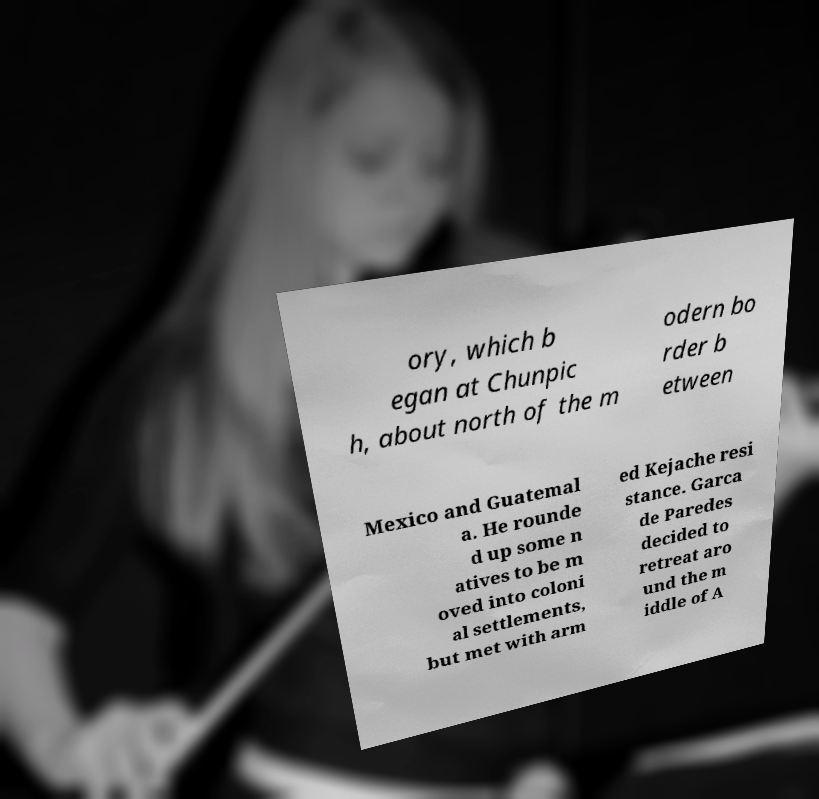Could you extract and type out the text from this image? ory, which b egan at Chunpic h, about north of the m odern bo rder b etween Mexico and Guatemal a. He rounde d up some n atives to be m oved into coloni al settlements, but met with arm ed Kejache resi stance. Garca de Paredes decided to retreat aro und the m iddle of A 